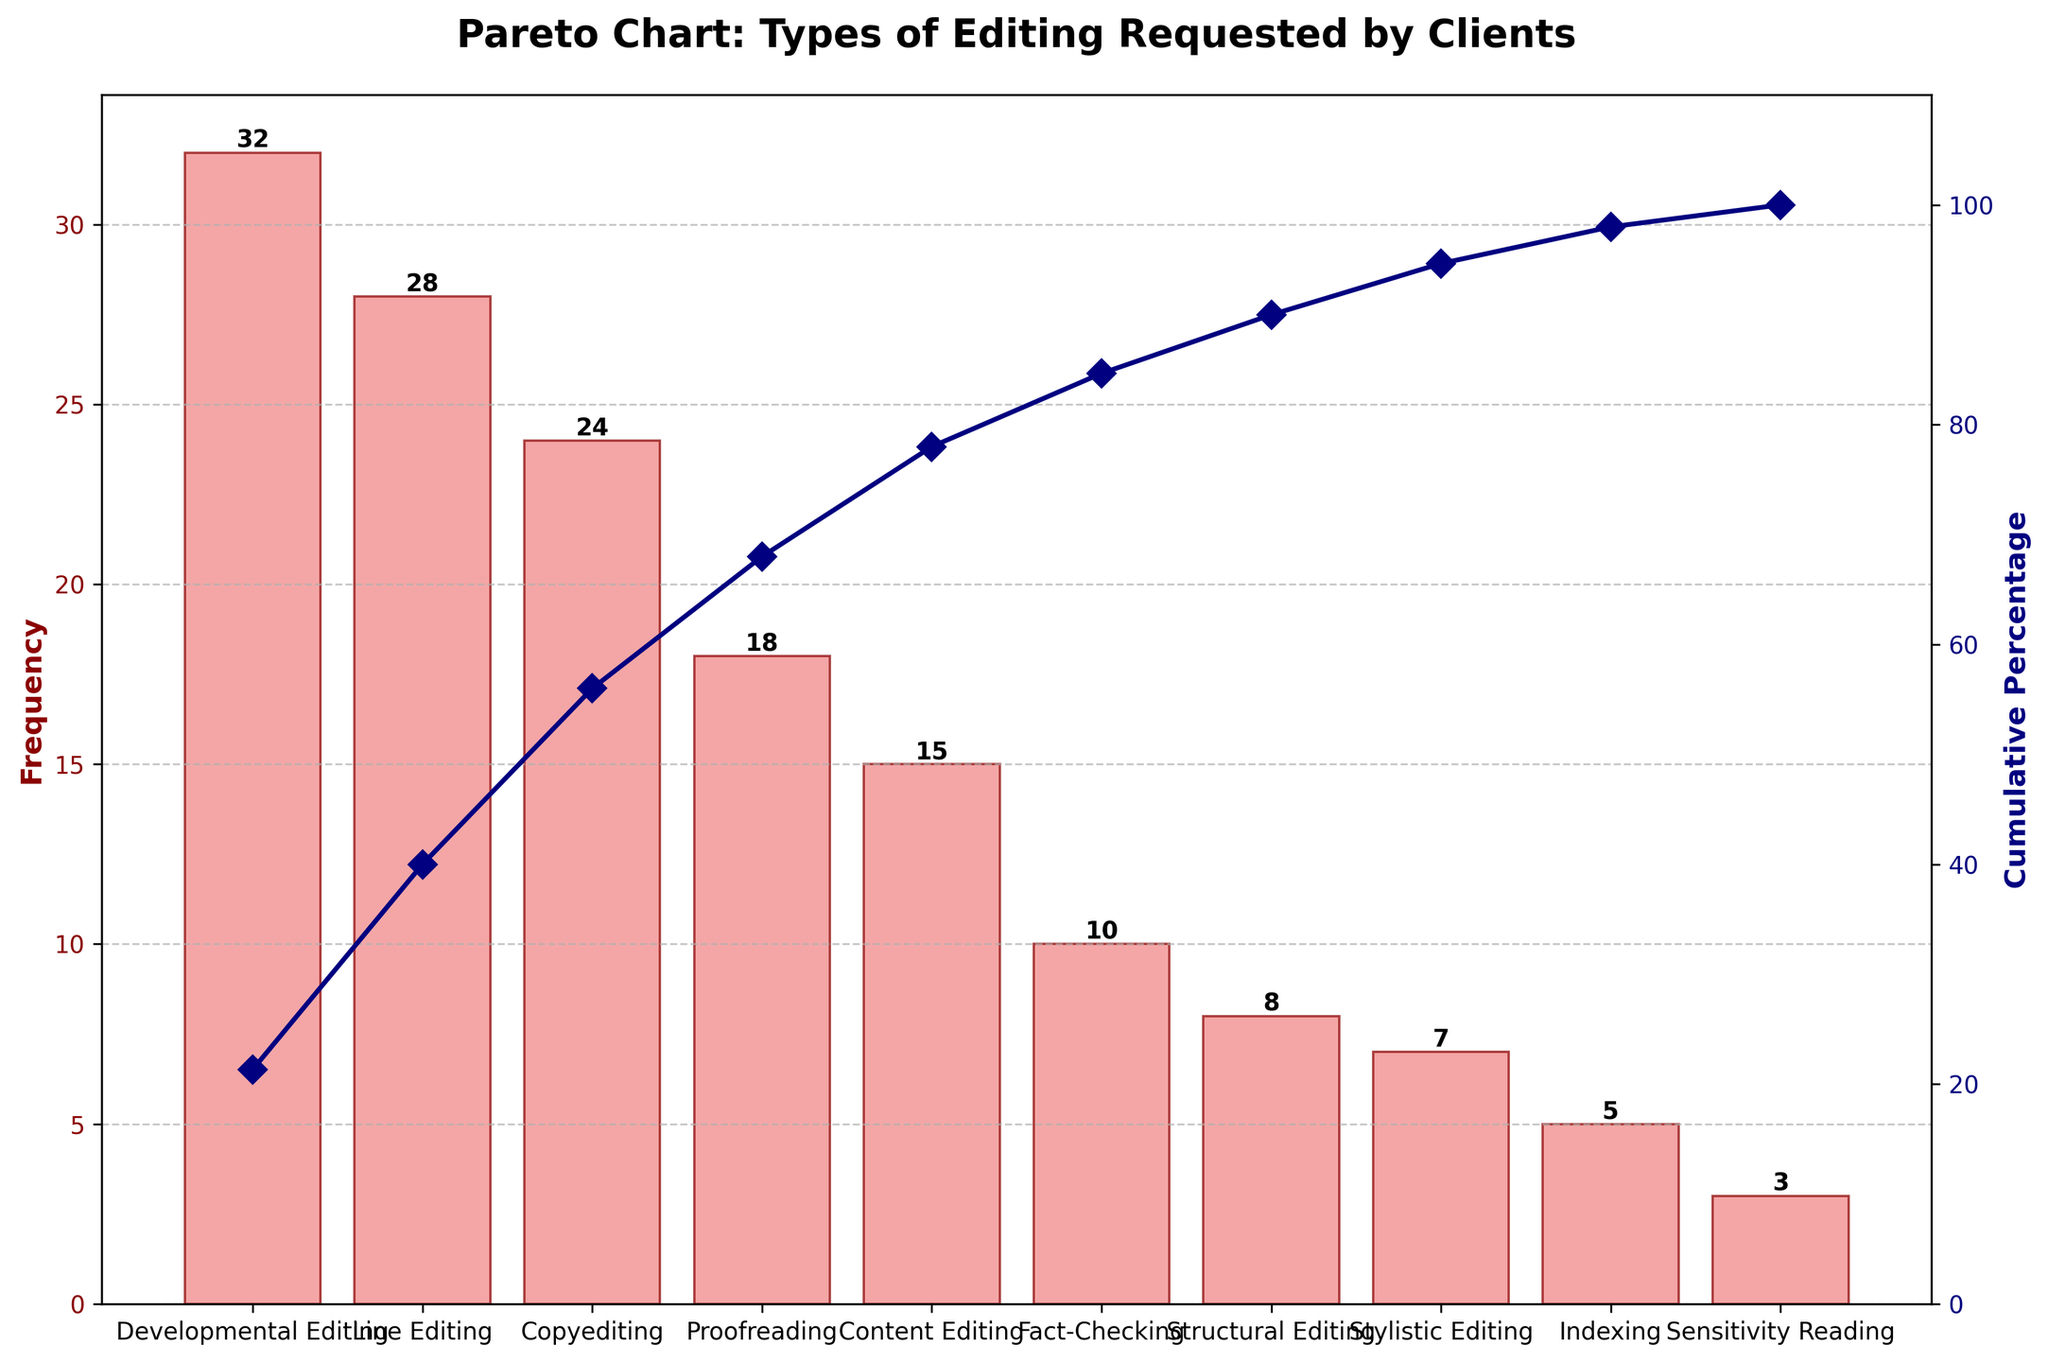What's the most frequently requested type of editing by clients? The most frequently requested type of editing can be seen by identifying the tallest bar in the bar chart. The title of the chart, "Pareto Chart: Types of Editing Requested by Clients", tells us what the chart is about. The tallest bar represents Developmental Editing with a height of 32.
Answer: Developmental Editing What percentage of the total requests does Copyediting represent? To find the percentage, look at the cumulative percentage line and the Copyediting bar. The cumulative percentage at the top of the Copyediting bar can be seen to be slightly above the 65% mark. Copyediting contributes around 24 to the total of 150, calculated as (24/150)*100 which is 16%.
Answer: 16% How many types of editing make up approximately 80% of the total requests? To determine this, follow the cumulative line until it reaches 80%. The line crosses around the fourth bar, which corresponds to Proofreading. Thus, four types—Developmental Editing, Line Editing, Copyediting, and Proofreading—make up approximately 80%.
Answer: 4 Which type of editing has the lowest frequency? The type of editing with the lowest frequency is represented by the shortest bar in the bar chart. Sensitivity Reading has the lowest frequency, with a value of 3.
Answer: Sensitivity Reading What is the combined frequency of Line Editing and Content Editing? The frequency of Line Editing is 28 and the frequency of Content Editing is 15. Add these together to get the combined frequency: 28 + 15 = 43.
Answer: 43 Which editing type has a frequency equal to half of Developmental Editing? Developmental Editing has a frequency of 32. Half of this is 32/2 = 16. Looking at the bars, there is no type with a frequency exactly 16, but Proofreading is close with a frequency of 18. However, since the question asks for "equal to", there is technically no such type.
Answer: None Compare the frequencies of Indexing and Sensitivity Reading. Which one is higher? Indexing has a frequency of 5, and Sensitivity Reading has a frequency of 3. By comparison, Indexing is higher.
Answer: Indexing What is the cumulative percentage after the third most frequent type of editing? The third most frequent type of editing is Copyediting. The cumulative percentage line at the top of the Copyediting bar is around 55%.
Answer: 55% How much more frequent is Fact-Checking compared to Sensitivity Reading? The frequency of Fact-Checking is 10, and the frequency of Sensitivity Reading is 3. The difference is 10 - 3 = 7.
Answer: 7 